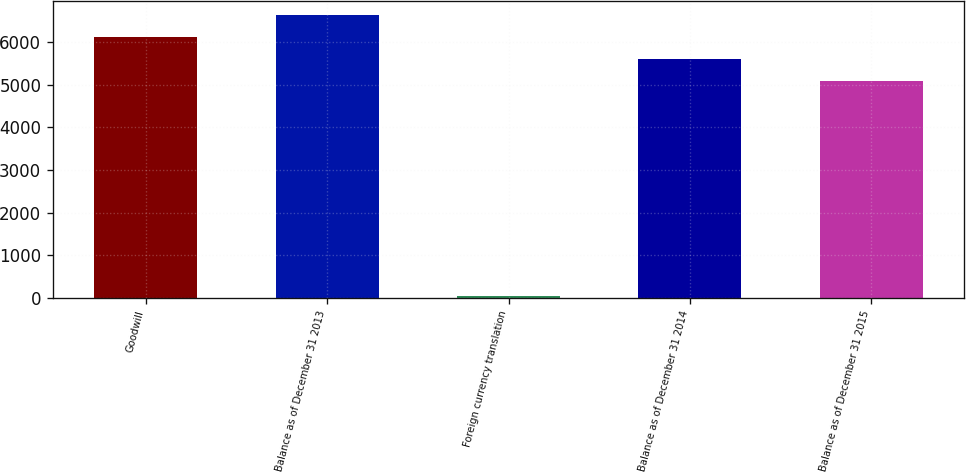Convert chart to OTSL. <chart><loc_0><loc_0><loc_500><loc_500><bar_chart><fcel>Goodwill<fcel>Balance as of December 31 2013<fcel>Foreign currency translation<fcel>Balance as of December 31 2014<fcel>Balance as of December 31 2015<nl><fcel>6112.8<fcel>6625.7<fcel>55<fcel>5599.9<fcel>5087<nl></chart> 